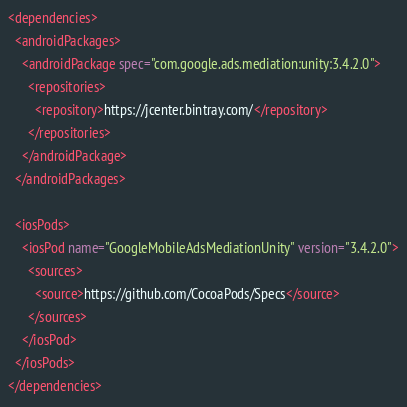<code> <loc_0><loc_0><loc_500><loc_500><_XML_><dependencies>
  <androidPackages>
    <androidPackage spec="com.google.ads.mediation:unity:3.4.2.0">
      <repositories>
        <repository>https://jcenter.bintray.com/</repository>
      </repositories>
    </androidPackage>
  </androidPackages>

  <iosPods>
    <iosPod name="GoogleMobileAdsMediationUnity" version="3.4.2.0">
      <sources>
        <source>https://github.com/CocoaPods/Specs</source>
      </sources>
    </iosPod>
  </iosPods>
</dependencies>
</code> 